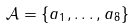Convert formula to latex. <formula><loc_0><loc_0><loc_500><loc_500>\mathcal { A } = \{ a _ { 1 } , \dots , a _ { 8 } \}</formula> 